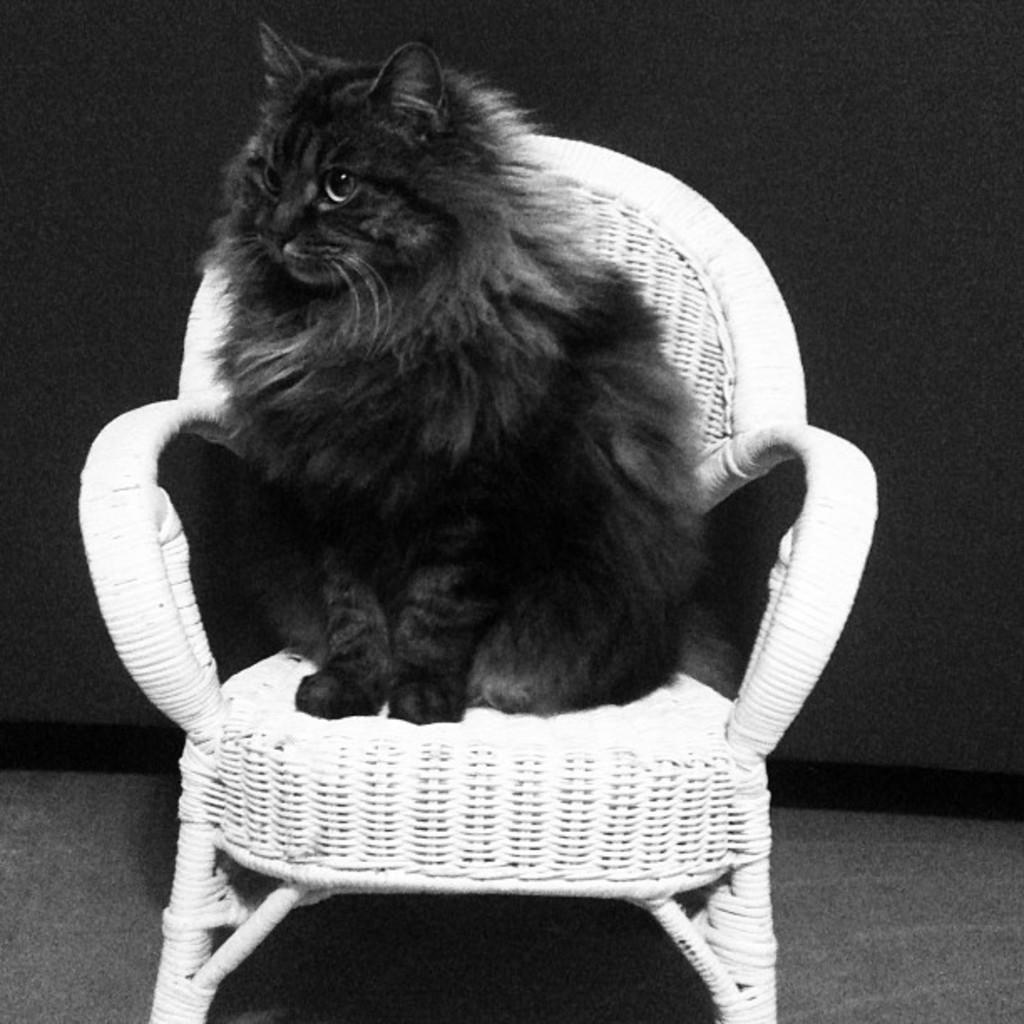What type of animal is in the image? There is a black color cat in the image. What is the cat sitting on? The cat is on a white color chair. How many pies are on the table in the image? There is no table or pies present in the image; it only features a black color cat on a white color chair. 